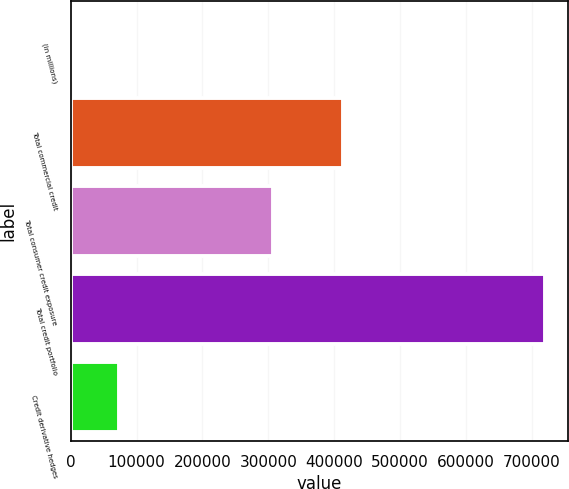Convert chart. <chart><loc_0><loc_0><loc_500><loc_500><bar_chart><fcel>(in millions)<fcel>Total commercial credit<fcel>Total consumer credit exposure<fcel>Total credit portfolio<fcel>Credit derivative hedges<nl><fcel>2002<fcel>412878<fcel>306676<fcel>719554<fcel>73757.2<nl></chart> 